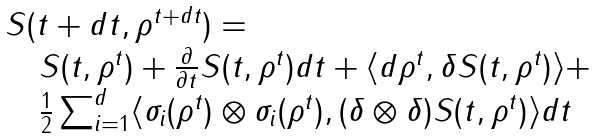<formula> <loc_0><loc_0><loc_500><loc_500>\begin{array} { l } S ( t + d t , \rho ^ { t + d t } ) = \\ \quad S ( t , \rho ^ { t } ) + \frac { \partial } { \partial t } S ( t , \rho ^ { t } ) d t + \langle d \rho ^ { t } , \delta S ( t , \rho ^ { t } ) \rangle + \\ \quad \frac { 1 } { 2 } \sum _ { i = 1 } ^ { d } \langle \sigma _ { i } ( \rho ^ { t } ) \otimes \sigma _ { i } ( \rho ^ { t } ) , ( \delta \otimes \delta ) S ( t , \rho ^ { t } ) \rangle d t \end{array}</formula> 